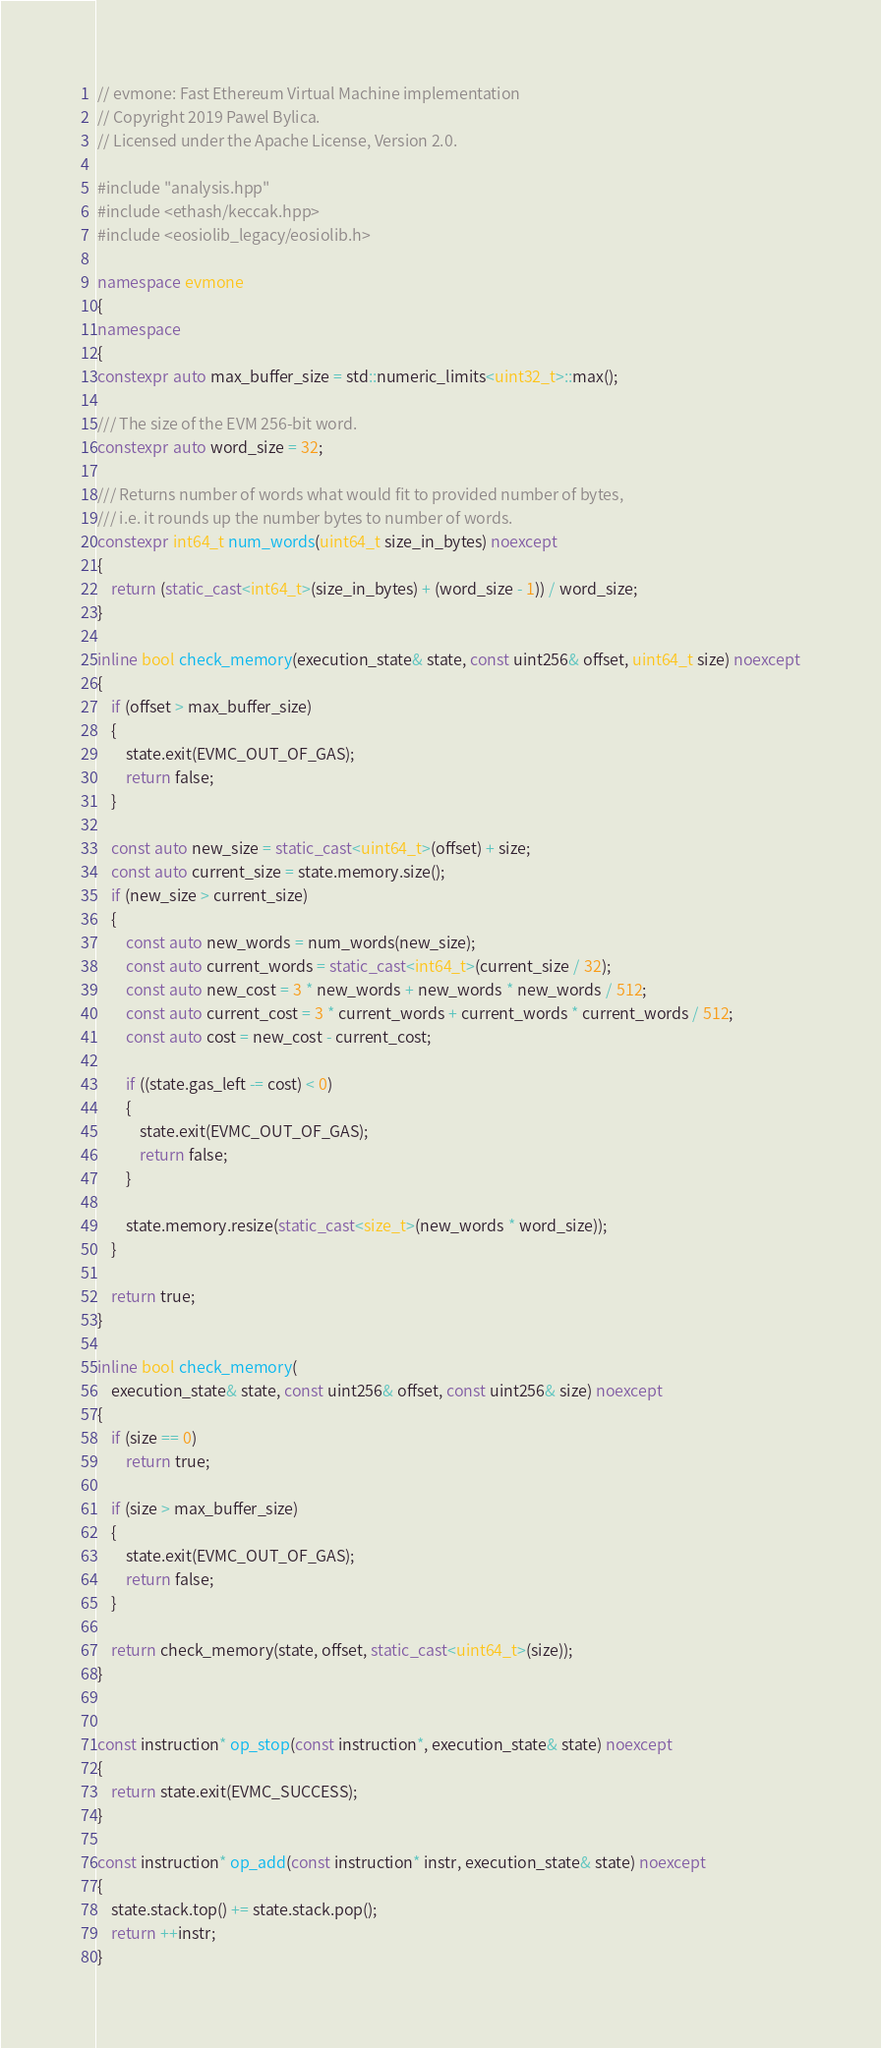<code> <loc_0><loc_0><loc_500><loc_500><_C++_>// evmone: Fast Ethereum Virtual Machine implementation
// Copyright 2019 Pawel Bylica.
// Licensed under the Apache License, Version 2.0.

#include "analysis.hpp"
#include <ethash/keccak.hpp>
#include <eosiolib_legacy/eosiolib.h>

namespace evmone
{
namespace
{
constexpr auto max_buffer_size = std::numeric_limits<uint32_t>::max();

/// The size of the EVM 256-bit word.
constexpr auto word_size = 32;

/// Returns number of words what would fit to provided number of bytes,
/// i.e. it rounds up the number bytes to number of words.
constexpr int64_t num_words(uint64_t size_in_bytes) noexcept
{
    return (static_cast<int64_t>(size_in_bytes) + (word_size - 1)) / word_size;
}

inline bool check_memory(execution_state& state, const uint256& offset, uint64_t size) noexcept
{
    if (offset > max_buffer_size)
    {
        state.exit(EVMC_OUT_OF_GAS);
        return false;
    }

    const auto new_size = static_cast<uint64_t>(offset) + size;
    const auto current_size = state.memory.size();
    if (new_size > current_size)
    {
        const auto new_words = num_words(new_size);
        const auto current_words = static_cast<int64_t>(current_size / 32);
        const auto new_cost = 3 * new_words + new_words * new_words / 512;
        const auto current_cost = 3 * current_words + current_words * current_words / 512;
        const auto cost = new_cost - current_cost;

        if ((state.gas_left -= cost) < 0)
        {
            state.exit(EVMC_OUT_OF_GAS);
            return false;
        }

        state.memory.resize(static_cast<size_t>(new_words * word_size));
    }

    return true;
}

inline bool check_memory(
    execution_state& state, const uint256& offset, const uint256& size) noexcept
{
    if (size == 0)
        return true;

    if (size > max_buffer_size)
    {
        state.exit(EVMC_OUT_OF_GAS);
        return false;
    }

    return check_memory(state, offset, static_cast<uint64_t>(size));
}


const instruction* op_stop(const instruction*, execution_state& state) noexcept
{
    return state.exit(EVMC_SUCCESS);
}

const instruction* op_add(const instruction* instr, execution_state& state) noexcept
{
    state.stack.top() += state.stack.pop();
    return ++instr;
}
</code> 